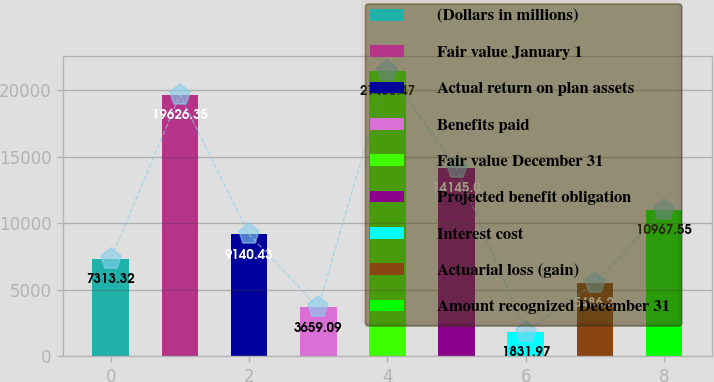Convert chart. <chart><loc_0><loc_0><loc_500><loc_500><bar_chart><fcel>(Dollars in millions)<fcel>Fair value January 1<fcel>Actual return on plan assets<fcel>Benefits paid<fcel>Fair value December 31<fcel>Projected benefit obligation<fcel>Interest cost<fcel>Actuarial loss (gain)<fcel>Amount recognized December 31<nl><fcel>7313.32<fcel>19626.3<fcel>9140.43<fcel>3659.09<fcel>21453.5<fcel>14145<fcel>1831.97<fcel>5486.2<fcel>10967.5<nl></chart> 